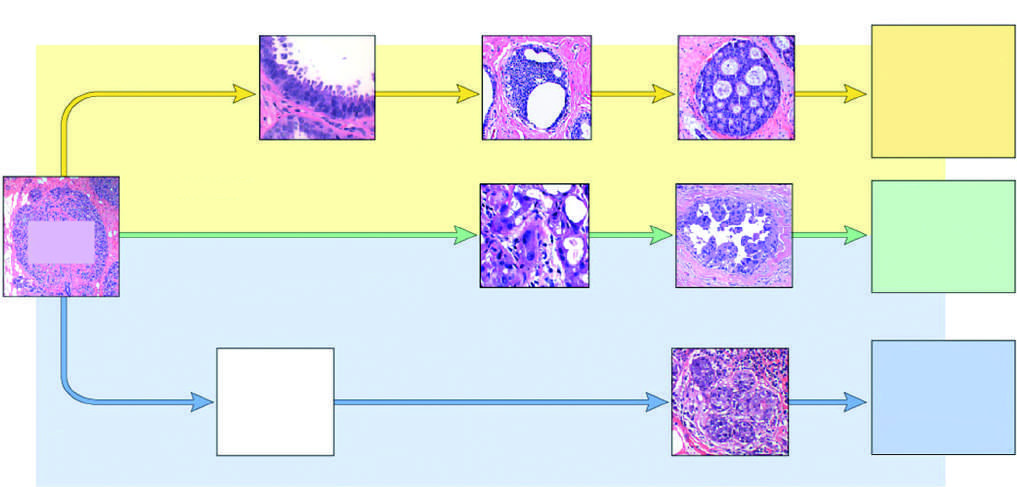what are classified as luminal by gene expression profiling?
Answer the question using a single word or phrase. Er-positive carcinomas 